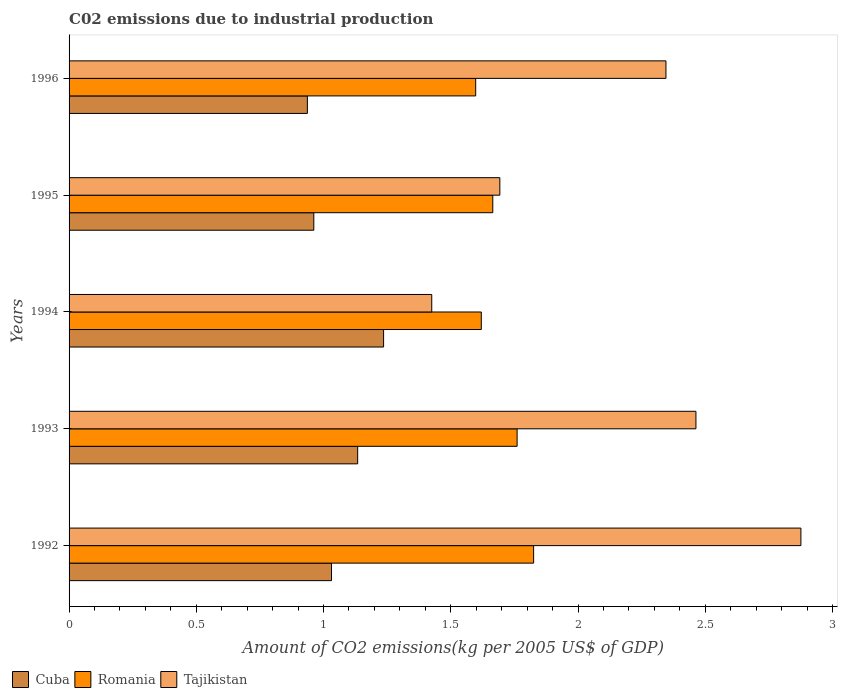Are the number of bars per tick equal to the number of legend labels?
Offer a terse response. Yes. Are the number of bars on each tick of the Y-axis equal?
Your response must be concise. Yes. How many bars are there on the 1st tick from the top?
Give a very brief answer. 3. What is the label of the 2nd group of bars from the top?
Ensure brevity in your answer.  1995. What is the amount of CO2 emitted due to industrial production in Tajikistan in 1994?
Offer a very short reply. 1.43. Across all years, what is the maximum amount of CO2 emitted due to industrial production in Romania?
Keep it short and to the point. 1.83. Across all years, what is the minimum amount of CO2 emitted due to industrial production in Romania?
Ensure brevity in your answer.  1.6. What is the total amount of CO2 emitted due to industrial production in Cuba in the graph?
Provide a succinct answer. 5.3. What is the difference between the amount of CO2 emitted due to industrial production in Tajikistan in 1995 and that in 1996?
Give a very brief answer. -0.65. What is the difference between the amount of CO2 emitted due to industrial production in Romania in 1993 and the amount of CO2 emitted due to industrial production in Tajikistan in 1996?
Your response must be concise. -0.58. What is the average amount of CO2 emitted due to industrial production in Cuba per year?
Your answer should be very brief. 1.06. In the year 1995, what is the difference between the amount of CO2 emitted due to industrial production in Romania and amount of CO2 emitted due to industrial production in Tajikistan?
Ensure brevity in your answer.  -0.03. What is the ratio of the amount of CO2 emitted due to industrial production in Tajikistan in 1993 to that in 1995?
Offer a terse response. 1.46. Is the amount of CO2 emitted due to industrial production in Romania in 1993 less than that in 1996?
Provide a succinct answer. No. Is the difference between the amount of CO2 emitted due to industrial production in Romania in 1992 and 1994 greater than the difference between the amount of CO2 emitted due to industrial production in Tajikistan in 1992 and 1994?
Give a very brief answer. No. What is the difference between the highest and the second highest amount of CO2 emitted due to industrial production in Romania?
Keep it short and to the point. 0.06. What is the difference between the highest and the lowest amount of CO2 emitted due to industrial production in Tajikistan?
Give a very brief answer. 1.45. In how many years, is the amount of CO2 emitted due to industrial production in Romania greater than the average amount of CO2 emitted due to industrial production in Romania taken over all years?
Give a very brief answer. 2. What does the 2nd bar from the top in 1996 represents?
Give a very brief answer. Romania. What does the 1st bar from the bottom in 1992 represents?
Offer a terse response. Cuba. Are all the bars in the graph horizontal?
Your response must be concise. Yes. Are the values on the major ticks of X-axis written in scientific E-notation?
Give a very brief answer. No. Does the graph contain grids?
Your answer should be compact. No. How many legend labels are there?
Offer a very short reply. 3. What is the title of the graph?
Make the answer very short. C02 emissions due to industrial production. Does "Samoa" appear as one of the legend labels in the graph?
Your response must be concise. No. What is the label or title of the X-axis?
Ensure brevity in your answer.  Amount of CO2 emissions(kg per 2005 US$ of GDP). What is the label or title of the Y-axis?
Your answer should be very brief. Years. What is the Amount of CO2 emissions(kg per 2005 US$ of GDP) of Cuba in 1992?
Your response must be concise. 1.03. What is the Amount of CO2 emissions(kg per 2005 US$ of GDP) of Romania in 1992?
Keep it short and to the point. 1.83. What is the Amount of CO2 emissions(kg per 2005 US$ of GDP) in Tajikistan in 1992?
Make the answer very short. 2.88. What is the Amount of CO2 emissions(kg per 2005 US$ of GDP) of Cuba in 1993?
Give a very brief answer. 1.13. What is the Amount of CO2 emissions(kg per 2005 US$ of GDP) in Romania in 1993?
Your answer should be very brief. 1.76. What is the Amount of CO2 emissions(kg per 2005 US$ of GDP) in Tajikistan in 1993?
Provide a succinct answer. 2.46. What is the Amount of CO2 emissions(kg per 2005 US$ of GDP) of Cuba in 1994?
Ensure brevity in your answer.  1.24. What is the Amount of CO2 emissions(kg per 2005 US$ of GDP) of Romania in 1994?
Provide a succinct answer. 1.62. What is the Amount of CO2 emissions(kg per 2005 US$ of GDP) in Tajikistan in 1994?
Ensure brevity in your answer.  1.43. What is the Amount of CO2 emissions(kg per 2005 US$ of GDP) of Cuba in 1995?
Your response must be concise. 0.96. What is the Amount of CO2 emissions(kg per 2005 US$ of GDP) in Romania in 1995?
Ensure brevity in your answer.  1.67. What is the Amount of CO2 emissions(kg per 2005 US$ of GDP) in Tajikistan in 1995?
Your response must be concise. 1.69. What is the Amount of CO2 emissions(kg per 2005 US$ of GDP) of Cuba in 1996?
Ensure brevity in your answer.  0.94. What is the Amount of CO2 emissions(kg per 2005 US$ of GDP) of Romania in 1996?
Offer a terse response. 1.6. What is the Amount of CO2 emissions(kg per 2005 US$ of GDP) in Tajikistan in 1996?
Offer a terse response. 2.35. Across all years, what is the maximum Amount of CO2 emissions(kg per 2005 US$ of GDP) in Cuba?
Keep it short and to the point. 1.24. Across all years, what is the maximum Amount of CO2 emissions(kg per 2005 US$ of GDP) of Romania?
Ensure brevity in your answer.  1.83. Across all years, what is the maximum Amount of CO2 emissions(kg per 2005 US$ of GDP) in Tajikistan?
Your response must be concise. 2.88. Across all years, what is the minimum Amount of CO2 emissions(kg per 2005 US$ of GDP) of Cuba?
Keep it short and to the point. 0.94. Across all years, what is the minimum Amount of CO2 emissions(kg per 2005 US$ of GDP) of Romania?
Your response must be concise. 1.6. Across all years, what is the minimum Amount of CO2 emissions(kg per 2005 US$ of GDP) of Tajikistan?
Make the answer very short. 1.43. What is the total Amount of CO2 emissions(kg per 2005 US$ of GDP) of Cuba in the graph?
Provide a succinct answer. 5.3. What is the total Amount of CO2 emissions(kg per 2005 US$ of GDP) of Romania in the graph?
Offer a very short reply. 8.47. What is the total Amount of CO2 emissions(kg per 2005 US$ of GDP) in Tajikistan in the graph?
Ensure brevity in your answer.  10.8. What is the difference between the Amount of CO2 emissions(kg per 2005 US$ of GDP) of Cuba in 1992 and that in 1993?
Offer a very short reply. -0.1. What is the difference between the Amount of CO2 emissions(kg per 2005 US$ of GDP) of Romania in 1992 and that in 1993?
Keep it short and to the point. 0.06. What is the difference between the Amount of CO2 emissions(kg per 2005 US$ of GDP) in Tajikistan in 1992 and that in 1993?
Offer a very short reply. 0.41. What is the difference between the Amount of CO2 emissions(kg per 2005 US$ of GDP) of Cuba in 1992 and that in 1994?
Ensure brevity in your answer.  -0.2. What is the difference between the Amount of CO2 emissions(kg per 2005 US$ of GDP) in Romania in 1992 and that in 1994?
Give a very brief answer. 0.21. What is the difference between the Amount of CO2 emissions(kg per 2005 US$ of GDP) of Tajikistan in 1992 and that in 1994?
Your answer should be very brief. 1.45. What is the difference between the Amount of CO2 emissions(kg per 2005 US$ of GDP) in Cuba in 1992 and that in 1995?
Your answer should be very brief. 0.07. What is the difference between the Amount of CO2 emissions(kg per 2005 US$ of GDP) of Romania in 1992 and that in 1995?
Ensure brevity in your answer.  0.16. What is the difference between the Amount of CO2 emissions(kg per 2005 US$ of GDP) of Tajikistan in 1992 and that in 1995?
Give a very brief answer. 1.18. What is the difference between the Amount of CO2 emissions(kg per 2005 US$ of GDP) of Cuba in 1992 and that in 1996?
Keep it short and to the point. 0.09. What is the difference between the Amount of CO2 emissions(kg per 2005 US$ of GDP) of Romania in 1992 and that in 1996?
Keep it short and to the point. 0.23. What is the difference between the Amount of CO2 emissions(kg per 2005 US$ of GDP) of Tajikistan in 1992 and that in 1996?
Keep it short and to the point. 0.53. What is the difference between the Amount of CO2 emissions(kg per 2005 US$ of GDP) of Cuba in 1993 and that in 1994?
Your answer should be very brief. -0.1. What is the difference between the Amount of CO2 emissions(kg per 2005 US$ of GDP) in Romania in 1993 and that in 1994?
Ensure brevity in your answer.  0.14. What is the difference between the Amount of CO2 emissions(kg per 2005 US$ of GDP) of Tajikistan in 1993 and that in 1994?
Offer a terse response. 1.04. What is the difference between the Amount of CO2 emissions(kg per 2005 US$ of GDP) in Cuba in 1993 and that in 1995?
Keep it short and to the point. 0.17. What is the difference between the Amount of CO2 emissions(kg per 2005 US$ of GDP) of Romania in 1993 and that in 1995?
Your response must be concise. 0.1. What is the difference between the Amount of CO2 emissions(kg per 2005 US$ of GDP) of Tajikistan in 1993 and that in 1995?
Ensure brevity in your answer.  0.77. What is the difference between the Amount of CO2 emissions(kg per 2005 US$ of GDP) of Cuba in 1993 and that in 1996?
Keep it short and to the point. 0.2. What is the difference between the Amount of CO2 emissions(kg per 2005 US$ of GDP) of Romania in 1993 and that in 1996?
Offer a very short reply. 0.16. What is the difference between the Amount of CO2 emissions(kg per 2005 US$ of GDP) in Tajikistan in 1993 and that in 1996?
Provide a succinct answer. 0.12. What is the difference between the Amount of CO2 emissions(kg per 2005 US$ of GDP) of Cuba in 1994 and that in 1995?
Offer a terse response. 0.27. What is the difference between the Amount of CO2 emissions(kg per 2005 US$ of GDP) of Romania in 1994 and that in 1995?
Give a very brief answer. -0.05. What is the difference between the Amount of CO2 emissions(kg per 2005 US$ of GDP) in Tajikistan in 1994 and that in 1995?
Make the answer very short. -0.27. What is the difference between the Amount of CO2 emissions(kg per 2005 US$ of GDP) in Cuba in 1994 and that in 1996?
Provide a short and direct response. 0.3. What is the difference between the Amount of CO2 emissions(kg per 2005 US$ of GDP) in Romania in 1994 and that in 1996?
Provide a short and direct response. 0.02. What is the difference between the Amount of CO2 emissions(kg per 2005 US$ of GDP) of Tajikistan in 1994 and that in 1996?
Give a very brief answer. -0.92. What is the difference between the Amount of CO2 emissions(kg per 2005 US$ of GDP) of Cuba in 1995 and that in 1996?
Your response must be concise. 0.03. What is the difference between the Amount of CO2 emissions(kg per 2005 US$ of GDP) in Romania in 1995 and that in 1996?
Give a very brief answer. 0.07. What is the difference between the Amount of CO2 emissions(kg per 2005 US$ of GDP) of Tajikistan in 1995 and that in 1996?
Your answer should be very brief. -0.65. What is the difference between the Amount of CO2 emissions(kg per 2005 US$ of GDP) in Cuba in 1992 and the Amount of CO2 emissions(kg per 2005 US$ of GDP) in Romania in 1993?
Provide a short and direct response. -0.73. What is the difference between the Amount of CO2 emissions(kg per 2005 US$ of GDP) of Cuba in 1992 and the Amount of CO2 emissions(kg per 2005 US$ of GDP) of Tajikistan in 1993?
Keep it short and to the point. -1.43. What is the difference between the Amount of CO2 emissions(kg per 2005 US$ of GDP) in Romania in 1992 and the Amount of CO2 emissions(kg per 2005 US$ of GDP) in Tajikistan in 1993?
Your answer should be compact. -0.64. What is the difference between the Amount of CO2 emissions(kg per 2005 US$ of GDP) of Cuba in 1992 and the Amount of CO2 emissions(kg per 2005 US$ of GDP) of Romania in 1994?
Provide a short and direct response. -0.59. What is the difference between the Amount of CO2 emissions(kg per 2005 US$ of GDP) of Cuba in 1992 and the Amount of CO2 emissions(kg per 2005 US$ of GDP) of Tajikistan in 1994?
Keep it short and to the point. -0.39. What is the difference between the Amount of CO2 emissions(kg per 2005 US$ of GDP) of Romania in 1992 and the Amount of CO2 emissions(kg per 2005 US$ of GDP) of Tajikistan in 1994?
Give a very brief answer. 0.4. What is the difference between the Amount of CO2 emissions(kg per 2005 US$ of GDP) of Cuba in 1992 and the Amount of CO2 emissions(kg per 2005 US$ of GDP) of Romania in 1995?
Your response must be concise. -0.63. What is the difference between the Amount of CO2 emissions(kg per 2005 US$ of GDP) of Cuba in 1992 and the Amount of CO2 emissions(kg per 2005 US$ of GDP) of Tajikistan in 1995?
Your answer should be compact. -0.66. What is the difference between the Amount of CO2 emissions(kg per 2005 US$ of GDP) in Romania in 1992 and the Amount of CO2 emissions(kg per 2005 US$ of GDP) in Tajikistan in 1995?
Give a very brief answer. 0.13. What is the difference between the Amount of CO2 emissions(kg per 2005 US$ of GDP) of Cuba in 1992 and the Amount of CO2 emissions(kg per 2005 US$ of GDP) of Romania in 1996?
Your answer should be very brief. -0.57. What is the difference between the Amount of CO2 emissions(kg per 2005 US$ of GDP) of Cuba in 1992 and the Amount of CO2 emissions(kg per 2005 US$ of GDP) of Tajikistan in 1996?
Ensure brevity in your answer.  -1.31. What is the difference between the Amount of CO2 emissions(kg per 2005 US$ of GDP) in Romania in 1992 and the Amount of CO2 emissions(kg per 2005 US$ of GDP) in Tajikistan in 1996?
Provide a succinct answer. -0.52. What is the difference between the Amount of CO2 emissions(kg per 2005 US$ of GDP) in Cuba in 1993 and the Amount of CO2 emissions(kg per 2005 US$ of GDP) in Romania in 1994?
Ensure brevity in your answer.  -0.49. What is the difference between the Amount of CO2 emissions(kg per 2005 US$ of GDP) in Cuba in 1993 and the Amount of CO2 emissions(kg per 2005 US$ of GDP) in Tajikistan in 1994?
Provide a succinct answer. -0.29. What is the difference between the Amount of CO2 emissions(kg per 2005 US$ of GDP) in Romania in 1993 and the Amount of CO2 emissions(kg per 2005 US$ of GDP) in Tajikistan in 1994?
Provide a succinct answer. 0.34. What is the difference between the Amount of CO2 emissions(kg per 2005 US$ of GDP) in Cuba in 1993 and the Amount of CO2 emissions(kg per 2005 US$ of GDP) in Romania in 1995?
Offer a terse response. -0.53. What is the difference between the Amount of CO2 emissions(kg per 2005 US$ of GDP) of Cuba in 1993 and the Amount of CO2 emissions(kg per 2005 US$ of GDP) of Tajikistan in 1995?
Give a very brief answer. -0.56. What is the difference between the Amount of CO2 emissions(kg per 2005 US$ of GDP) of Romania in 1993 and the Amount of CO2 emissions(kg per 2005 US$ of GDP) of Tajikistan in 1995?
Your answer should be very brief. 0.07. What is the difference between the Amount of CO2 emissions(kg per 2005 US$ of GDP) in Cuba in 1993 and the Amount of CO2 emissions(kg per 2005 US$ of GDP) in Romania in 1996?
Your answer should be very brief. -0.46. What is the difference between the Amount of CO2 emissions(kg per 2005 US$ of GDP) of Cuba in 1993 and the Amount of CO2 emissions(kg per 2005 US$ of GDP) of Tajikistan in 1996?
Offer a terse response. -1.21. What is the difference between the Amount of CO2 emissions(kg per 2005 US$ of GDP) of Romania in 1993 and the Amount of CO2 emissions(kg per 2005 US$ of GDP) of Tajikistan in 1996?
Make the answer very short. -0.58. What is the difference between the Amount of CO2 emissions(kg per 2005 US$ of GDP) in Cuba in 1994 and the Amount of CO2 emissions(kg per 2005 US$ of GDP) in Romania in 1995?
Make the answer very short. -0.43. What is the difference between the Amount of CO2 emissions(kg per 2005 US$ of GDP) of Cuba in 1994 and the Amount of CO2 emissions(kg per 2005 US$ of GDP) of Tajikistan in 1995?
Ensure brevity in your answer.  -0.46. What is the difference between the Amount of CO2 emissions(kg per 2005 US$ of GDP) in Romania in 1994 and the Amount of CO2 emissions(kg per 2005 US$ of GDP) in Tajikistan in 1995?
Offer a terse response. -0.07. What is the difference between the Amount of CO2 emissions(kg per 2005 US$ of GDP) in Cuba in 1994 and the Amount of CO2 emissions(kg per 2005 US$ of GDP) in Romania in 1996?
Your response must be concise. -0.36. What is the difference between the Amount of CO2 emissions(kg per 2005 US$ of GDP) of Cuba in 1994 and the Amount of CO2 emissions(kg per 2005 US$ of GDP) of Tajikistan in 1996?
Offer a terse response. -1.11. What is the difference between the Amount of CO2 emissions(kg per 2005 US$ of GDP) of Romania in 1994 and the Amount of CO2 emissions(kg per 2005 US$ of GDP) of Tajikistan in 1996?
Make the answer very short. -0.73. What is the difference between the Amount of CO2 emissions(kg per 2005 US$ of GDP) in Cuba in 1995 and the Amount of CO2 emissions(kg per 2005 US$ of GDP) in Romania in 1996?
Your response must be concise. -0.64. What is the difference between the Amount of CO2 emissions(kg per 2005 US$ of GDP) of Cuba in 1995 and the Amount of CO2 emissions(kg per 2005 US$ of GDP) of Tajikistan in 1996?
Ensure brevity in your answer.  -1.38. What is the difference between the Amount of CO2 emissions(kg per 2005 US$ of GDP) in Romania in 1995 and the Amount of CO2 emissions(kg per 2005 US$ of GDP) in Tajikistan in 1996?
Provide a short and direct response. -0.68. What is the average Amount of CO2 emissions(kg per 2005 US$ of GDP) in Cuba per year?
Give a very brief answer. 1.06. What is the average Amount of CO2 emissions(kg per 2005 US$ of GDP) in Romania per year?
Keep it short and to the point. 1.69. What is the average Amount of CO2 emissions(kg per 2005 US$ of GDP) of Tajikistan per year?
Your response must be concise. 2.16. In the year 1992, what is the difference between the Amount of CO2 emissions(kg per 2005 US$ of GDP) in Cuba and Amount of CO2 emissions(kg per 2005 US$ of GDP) in Romania?
Your answer should be compact. -0.79. In the year 1992, what is the difference between the Amount of CO2 emissions(kg per 2005 US$ of GDP) in Cuba and Amount of CO2 emissions(kg per 2005 US$ of GDP) in Tajikistan?
Your response must be concise. -1.84. In the year 1992, what is the difference between the Amount of CO2 emissions(kg per 2005 US$ of GDP) of Romania and Amount of CO2 emissions(kg per 2005 US$ of GDP) of Tajikistan?
Ensure brevity in your answer.  -1.05. In the year 1993, what is the difference between the Amount of CO2 emissions(kg per 2005 US$ of GDP) in Cuba and Amount of CO2 emissions(kg per 2005 US$ of GDP) in Romania?
Provide a short and direct response. -0.63. In the year 1993, what is the difference between the Amount of CO2 emissions(kg per 2005 US$ of GDP) in Cuba and Amount of CO2 emissions(kg per 2005 US$ of GDP) in Tajikistan?
Ensure brevity in your answer.  -1.33. In the year 1993, what is the difference between the Amount of CO2 emissions(kg per 2005 US$ of GDP) of Romania and Amount of CO2 emissions(kg per 2005 US$ of GDP) of Tajikistan?
Offer a very short reply. -0.7. In the year 1994, what is the difference between the Amount of CO2 emissions(kg per 2005 US$ of GDP) of Cuba and Amount of CO2 emissions(kg per 2005 US$ of GDP) of Romania?
Give a very brief answer. -0.38. In the year 1994, what is the difference between the Amount of CO2 emissions(kg per 2005 US$ of GDP) in Cuba and Amount of CO2 emissions(kg per 2005 US$ of GDP) in Tajikistan?
Your answer should be compact. -0.19. In the year 1994, what is the difference between the Amount of CO2 emissions(kg per 2005 US$ of GDP) in Romania and Amount of CO2 emissions(kg per 2005 US$ of GDP) in Tajikistan?
Offer a terse response. 0.19. In the year 1995, what is the difference between the Amount of CO2 emissions(kg per 2005 US$ of GDP) of Cuba and Amount of CO2 emissions(kg per 2005 US$ of GDP) of Romania?
Provide a short and direct response. -0.7. In the year 1995, what is the difference between the Amount of CO2 emissions(kg per 2005 US$ of GDP) in Cuba and Amount of CO2 emissions(kg per 2005 US$ of GDP) in Tajikistan?
Offer a very short reply. -0.73. In the year 1995, what is the difference between the Amount of CO2 emissions(kg per 2005 US$ of GDP) in Romania and Amount of CO2 emissions(kg per 2005 US$ of GDP) in Tajikistan?
Ensure brevity in your answer.  -0.03. In the year 1996, what is the difference between the Amount of CO2 emissions(kg per 2005 US$ of GDP) of Cuba and Amount of CO2 emissions(kg per 2005 US$ of GDP) of Romania?
Your response must be concise. -0.66. In the year 1996, what is the difference between the Amount of CO2 emissions(kg per 2005 US$ of GDP) in Cuba and Amount of CO2 emissions(kg per 2005 US$ of GDP) in Tajikistan?
Provide a short and direct response. -1.41. In the year 1996, what is the difference between the Amount of CO2 emissions(kg per 2005 US$ of GDP) in Romania and Amount of CO2 emissions(kg per 2005 US$ of GDP) in Tajikistan?
Offer a very short reply. -0.75. What is the ratio of the Amount of CO2 emissions(kg per 2005 US$ of GDP) in Cuba in 1992 to that in 1993?
Your answer should be compact. 0.91. What is the ratio of the Amount of CO2 emissions(kg per 2005 US$ of GDP) of Romania in 1992 to that in 1993?
Offer a terse response. 1.04. What is the ratio of the Amount of CO2 emissions(kg per 2005 US$ of GDP) of Tajikistan in 1992 to that in 1993?
Make the answer very short. 1.17. What is the ratio of the Amount of CO2 emissions(kg per 2005 US$ of GDP) of Cuba in 1992 to that in 1994?
Give a very brief answer. 0.83. What is the ratio of the Amount of CO2 emissions(kg per 2005 US$ of GDP) of Romania in 1992 to that in 1994?
Provide a succinct answer. 1.13. What is the ratio of the Amount of CO2 emissions(kg per 2005 US$ of GDP) of Tajikistan in 1992 to that in 1994?
Offer a terse response. 2.02. What is the ratio of the Amount of CO2 emissions(kg per 2005 US$ of GDP) in Cuba in 1992 to that in 1995?
Your answer should be compact. 1.07. What is the ratio of the Amount of CO2 emissions(kg per 2005 US$ of GDP) of Romania in 1992 to that in 1995?
Offer a very short reply. 1.1. What is the ratio of the Amount of CO2 emissions(kg per 2005 US$ of GDP) in Tajikistan in 1992 to that in 1995?
Offer a terse response. 1.7. What is the ratio of the Amount of CO2 emissions(kg per 2005 US$ of GDP) of Cuba in 1992 to that in 1996?
Your response must be concise. 1.1. What is the ratio of the Amount of CO2 emissions(kg per 2005 US$ of GDP) in Romania in 1992 to that in 1996?
Give a very brief answer. 1.14. What is the ratio of the Amount of CO2 emissions(kg per 2005 US$ of GDP) of Tajikistan in 1992 to that in 1996?
Provide a short and direct response. 1.23. What is the ratio of the Amount of CO2 emissions(kg per 2005 US$ of GDP) of Cuba in 1993 to that in 1994?
Your response must be concise. 0.92. What is the ratio of the Amount of CO2 emissions(kg per 2005 US$ of GDP) of Romania in 1993 to that in 1994?
Your answer should be compact. 1.09. What is the ratio of the Amount of CO2 emissions(kg per 2005 US$ of GDP) in Tajikistan in 1993 to that in 1994?
Offer a terse response. 1.73. What is the ratio of the Amount of CO2 emissions(kg per 2005 US$ of GDP) in Cuba in 1993 to that in 1995?
Offer a terse response. 1.18. What is the ratio of the Amount of CO2 emissions(kg per 2005 US$ of GDP) of Romania in 1993 to that in 1995?
Your response must be concise. 1.06. What is the ratio of the Amount of CO2 emissions(kg per 2005 US$ of GDP) of Tajikistan in 1993 to that in 1995?
Offer a very short reply. 1.46. What is the ratio of the Amount of CO2 emissions(kg per 2005 US$ of GDP) in Cuba in 1993 to that in 1996?
Ensure brevity in your answer.  1.21. What is the ratio of the Amount of CO2 emissions(kg per 2005 US$ of GDP) in Romania in 1993 to that in 1996?
Your answer should be compact. 1.1. What is the ratio of the Amount of CO2 emissions(kg per 2005 US$ of GDP) in Tajikistan in 1993 to that in 1996?
Provide a succinct answer. 1.05. What is the ratio of the Amount of CO2 emissions(kg per 2005 US$ of GDP) of Cuba in 1994 to that in 1995?
Make the answer very short. 1.29. What is the ratio of the Amount of CO2 emissions(kg per 2005 US$ of GDP) of Romania in 1994 to that in 1995?
Offer a terse response. 0.97. What is the ratio of the Amount of CO2 emissions(kg per 2005 US$ of GDP) in Tajikistan in 1994 to that in 1995?
Your answer should be very brief. 0.84. What is the ratio of the Amount of CO2 emissions(kg per 2005 US$ of GDP) of Cuba in 1994 to that in 1996?
Provide a succinct answer. 1.32. What is the ratio of the Amount of CO2 emissions(kg per 2005 US$ of GDP) of Romania in 1994 to that in 1996?
Ensure brevity in your answer.  1.01. What is the ratio of the Amount of CO2 emissions(kg per 2005 US$ of GDP) of Tajikistan in 1994 to that in 1996?
Your answer should be compact. 0.61. What is the ratio of the Amount of CO2 emissions(kg per 2005 US$ of GDP) of Romania in 1995 to that in 1996?
Provide a succinct answer. 1.04. What is the ratio of the Amount of CO2 emissions(kg per 2005 US$ of GDP) in Tajikistan in 1995 to that in 1996?
Offer a very short reply. 0.72. What is the difference between the highest and the second highest Amount of CO2 emissions(kg per 2005 US$ of GDP) of Cuba?
Your response must be concise. 0.1. What is the difference between the highest and the second highest Amount of CO2 emissions(kg per 2005 US$ of GDP) of Romania?
Ensure brevity in your answer.  0.06. What is the difference between the highest and the second highest Amount of CO2 emissions(kg per 2005 US$ of GDP) in Tajikistan?
Provide a short and direct response. 0.41. What is the difference between the highest and the lowest Amount of CO2 emissions(kg per 2005 US$ of GDP) in Cuba?
Keep it short and to the point. 0.3. What is the difference between the highest and the lowest Amount of CO2 emissions(kg per 2005 US$ of GDP) of Romania?
Provide a succinct answer. 0.23. What is the difference between the highest and the lowest Amount of CO2 emissions(kg per 2005 US$ of GDP) in Tajikistan?
Provide a short and direct response. 1.45. 